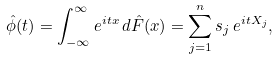Convert formula to latex. <formula><loc_0><loc_0><loc_500><loc_500>\hat { \phi } ( t ) & = \int _ { - \infty } ^ { \infty } e ^ { i t x } \, d \hat { F } ( x ) = \sum _ { j = 1 } ^ { n } s _ { j } \, e ^ { i t X _ { j } } ,</formula> 